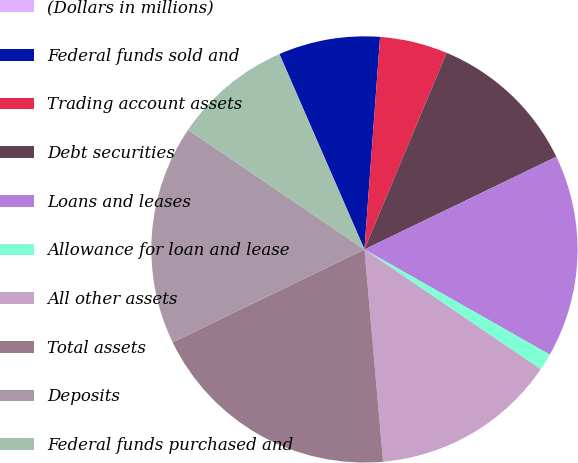Convert chart. <chart><loc_0><loc_0><loc_500><loc_500><pie_chart><fcel>(Dollars in millions)<fcel>Federal funds sold and<fcel>Trading account assets<fcel>Debt securities<fcel>Loans and leases<fcel>Allowance for loan and lease<fcel>All other assets<fcel>Total assets<fcel>Deposits<fcel>Federal funds purchased and<nl><fcel>0.01%<fcel>7.7%<fcel>5.13%<fcel>11.54%<fcel>15.38%<fcel>1.29%<fcel>14.1%<fcel>19.22%<fcel>16.66%<fcel>8.98%<nl></chart> 